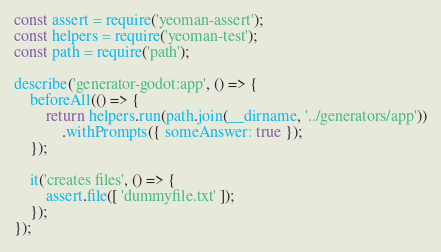Convert code to text. <code><loc_0><loc_0><loc_500><loc_500><_JavaScript_>const assert = require('yeoman-assert');
const helpers = require('yeoman-test');
const path = require('path');

describe('generator-godot:app', () => {
	beforeAll(() => {
		return helpers.run(path.join(__dirname, '../generators/app'))
			.withPrompts({ someAnswer: true });
	});

	it('creates files', () => {
		assert.file([ 'dummyfile.txt' ]);
	});
});
</code> 